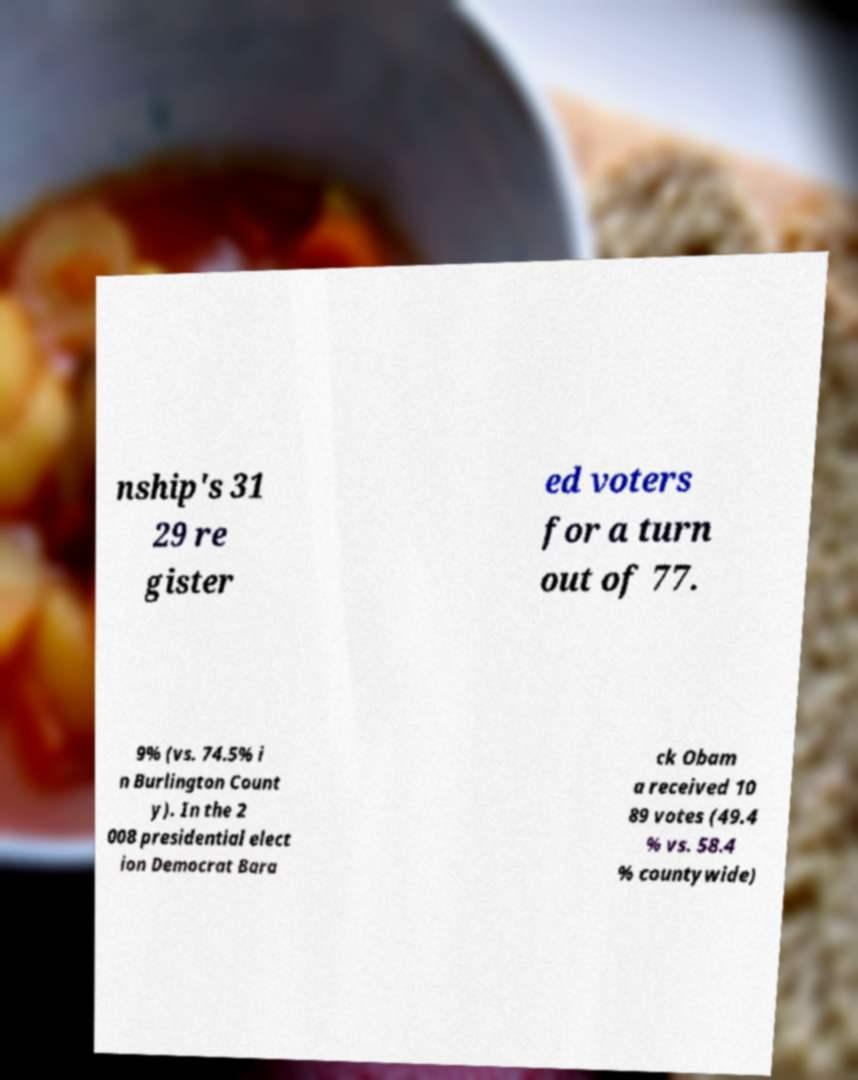There's text embedded in this image that I need extracted. Can you transcribe it verbatim? nship's 31 29 re gister ed voters for a turn out of 77. 9% (vs. 74.5% i n Burlington Count y). In the 2 008 presidential elect ion Democrat Bara ck Obam a received 10 89 votes (49.4 % vs. 58.4 % countywide) 